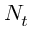<formula> <loc_0><loc_0><loc_500><loc_500>N _ { t }</formula> 